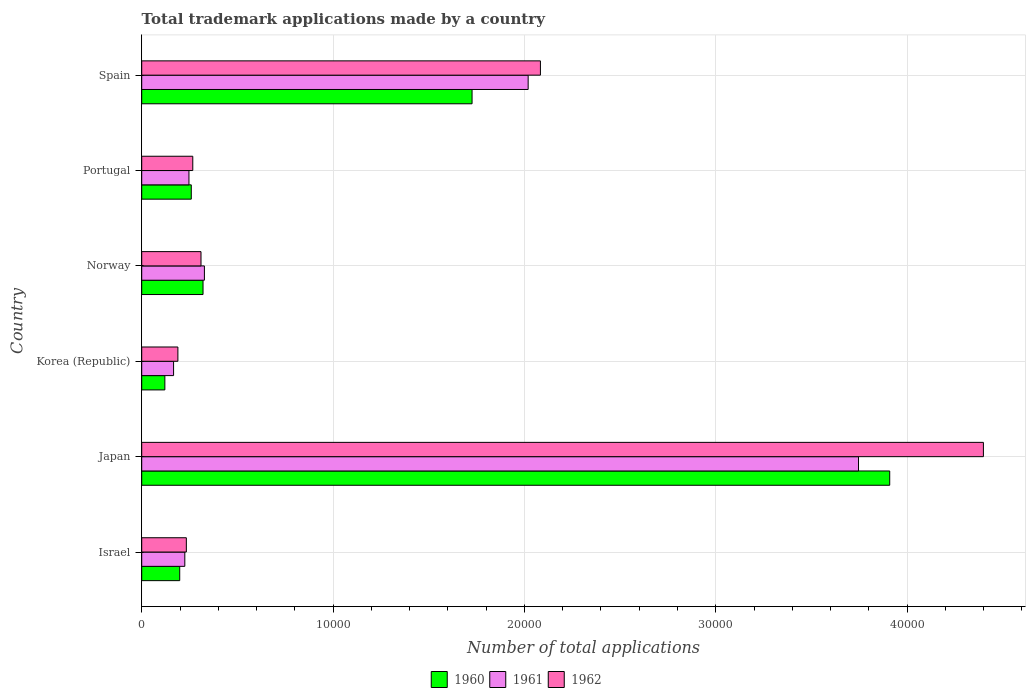Are the number of bars per tick equal to the number of legend labels?
Provide a succinct answer. Yes. Are the number of bars on each tick of the Y-axis equal?
Keep it short and to the point. Yes. What is the number of applications made by in 1960 in Korea (Republic)?
Your answer should be compact. 1209. Across all countries, what is the maximum number of applications made by in 1962?
Provide a succinct answer. 4.40e+04. Across all countries, what is the minimum number of applications made by in 1961?
Provide a short and direct response. 1665. In which country was the number of applications made by in 1962 maximum?
Your answer should be compact. Japan. What is the total number of applications made by in 1960 in the graph?
Your answer should be very brief. 6.53e+04. What is the difference between the number of applications made by in 1961 in Israel and that in Portugal?
Give a very brief answer. -216. What is the difference between the number of applications made by in 1962 in Israel and the number of applications made by in 1960 in Japan?
Make the answer very short. -3.68e+04. What is the average number of applications made by in 1961 per country?
Give a very brief answer. 1.12e+04. What is the difference between the number of applications made by in 1961 and number of applications made by in 1962 in Norway?
Provide a short and direct response. 178. In how many countries, is the number of applications made by in 1960 greater than 4000 ?
Keep it short and to the point. 2. What is the ratio of the number of applications made by in 1962 in Israel to that in Japan?
Give a very brief answer. 0.05. What is the difference between the highest and the second highest number of applications made by in 1962?
Your answer should be very brief. 2.32e+04. What is the difference between the highest and the lowest number of applications made by in 1961?
Keep it short and to the point. 3.58e+04. In how many countries, is the number of applications made by in 1962 greater than the average number of applications made by in 1962 taken over all countries?
Offer a terse response. 2. Is the sum of the number of applications made by in 1962 in Israel and Portugal greater than the maximum number of applications made by in 1961 across all countries?
Your answer should be compact. No. What does the 3rd bar from the top in Norway represents?
Keep it short and to the point. 1960. Is it the case that in every country, the sum of the number of applications made by in 1962 and number of applications made by in 1960 is greater than the number of applications made by in 1961?
Your answer should be compact. Yes. What is the difference between two consecutive major ticks on the X-axis?
Make the answer very short. 10000. Does the graph contain grids?
Give a very brief answer. Yes. Where does the legend appear in the graph?
Your response must be concise. Bottom center. What is the title of the graph?
Give a very brief answer. Total trademark applications made by a country. Does "1969" appear as one of the legend labels in the graph?
Offer a very short reply. No. What is the label or title of the X-axis?
Your answer should be compact. Number of total applications. What is the Number of total applications in 1960 in Israel?
Give a very brief answer. 1986. What is the Number of total applications of 1961 in Israel?
Give a very brief answer. 2252. What is the Number of total applications in 1962 in Israel?
Your response must be concise. 2332. What is the Number of total applications of 1960 in Japan?
Provide a succinct answer. 3.91e+04. What is the Number of total applications in 1961 in Japan?
Provide a short and direct response. 3.75e+04. What is the Number of total applications of 1962 in Japan?
Provide a short and direct response. 4.40e+04. What is the Number of total applications of 1960 in Korea (Republic)?
Your answer should be very brief. 1209. What is the Number of total applications in 1961 in Korea (Republic)?
Offer a very short reply. 1665. What is the Number of total applications of 1962 in Korea (Republic)?
Provide a short and direct response. 1890. What is the Number of total applications in 1960 in Norway?
Offer a terse response. 3204. What is the Number of total applications in 1961 in Norway?
Provide a succinct answer. 3276. What is the Number of total applications in 1962 in Norway?
Your answer should be very brief. 3098. What is the Number of total applications in 1960 in Portugal?
Keep it short and to the point. 2590. What is the Number of total applications in 1961 in Portugal?
Offer a terse response. 2468. What is the Number of total applications of 1962 in Portugal?
Give a very brief answer. 2668. What is the Number of total applications of 1960 in Spain?
Offer a terse response. 1.73e+04. What is the Number of total applications of 1961 in Spain?
Your answer should be very brief. 2.02e+04. What is the Number of total applications of 1962 in Spain?
Offer a very short reply. 2.08e+04. Across all countries, what is the maximum Number of total applications of 1960?
Your answer should be compact. 3.91e+04. Across all countries, what is the maximum Number of total applications of 1961?
Provide a short and direct response. 3.75e+04. Across all countries, what is the maximum Number of total applications of 1962?
Keep it short and to the point. 4.40e+04. Across all countries, what is the minimum Number of total applications of 1960?
Keep it short and to the point. 1209. Across all countries, what is the minimum Number of total applications of 1961?
Your answer should be very brief. 1665. Across all countries, what is the minimum Number of total applications of 1962?
Your answer should be very brief. 1890. What is the total Number of total applications in 1960 in the graph?
Give a very brief answer. 6.53e+04. What is the total Number of total applications in 1961 in the graph?
Provide a short and direct response. 6.73e+04. What is the total Number of total applications in 1962 in the graph?
Your answer should be compact. 7.48e+04. What is the difference between the Number of total applications in 1960 in Israel and that in Japan?
Offer a terse response. -3.71e+04. What is the difference between the Number of total applications in 1961 in Israel and that in Japan?
Make the answer very short. -3.52e+04. What is the difference between the Number of total applications in 1962 in Israel and that in Japan?
Provide a succinct answer. -4.17e+04. What is the difference between the Number of total applications in 1960 in Israel and that in Korea (Republic)?
Your answer should be compact. 777. What is the difference between the Number of total applications of 1961 in Israel and that in Korea (Republic)?
Provide a short and direct response. 587. What is the difference between the Number of total applications in 1962 in Israel and that in Korea (Republic)?
Your answer should be very brief. 442. What is the difference between the Number of total applications of 1960 in Israel and that in Norway?
Offer a terse response. -1218. What is the difference between the Number of total applications of 1961 in Israel and that in Norway?
Ensure brevity in your answer.  -1024. What is the difference between the Number of total applications in 1962 in Israel and that in Norway?
Offer a very short reply. -766. What is the difference between the Number of total applications in 1960 in Israel and that in Portugal?
Offer a terse response. -604. What is the difference between the Number of total applications of 1961 in Israel and that in Portugal?
Your answer should be very brief. -216. What is the difference between the Number of total applications in 1962 in Israel and that in Portugal?
Ensure brevity in your answer.  -336. What is the difference between the Number of total applications in 1960 in Israel and that in Spain?
Keep it short and to the point. -1.53e+04. What is the difference between the Number of total applications of 1961 in Israel and that in Spain?
Your answer should be very brief. -1.79e+04. What is the difference between the Number of total applications in 1962 in Israel and that in Spain?
Your answer should be compact. -1.85e+04. What is the difference between the Number of total applications of 1960 in Japan and that in Korea (Republic)?
Give a very brief answer. 3.79e+04. What is the difference between the Number of total applications of 1961 in Japan and that in Korea (Republic)?
Keep it short and to the point. 3.58e+04. What is the difference between the Number of total applications in 1962 in Japan and that in Korea (Republic)?
Your answer should be very brief. 4.21e+04. What is the difference between the Number of total applications in 1960 in Japan and that in Norway?
Offer a terse response. 3.59e+04. What is the difference between the Number of total applications of 1961 in Japan and that in Norway?
Give a very brief answer. 3.42e+04. What is the difference between the Number of total applications in 1962 in Japan and that in Norway?
Your answer should be compact. 4.09e+04. What is the difference between the Number of total applications of 1960 in Japan and that in Portugal?
Give a very brief answer. 3.65e+04. What is the difference between the Number of total applications of 1961 in Japan and that in Portugal?
Provide a short and direct response. 3.50e+04. What is the difference between the Number of total applications in 1962 in Japan and that in Portugal?
Ensure brevity in your answer.  4.13e+04. What is the difference between the Number of total applications in 1960 in Japan and that in Spain?
Ensure brevity in your answer.  2.18e+04. What is the difference between the Number of total applications in 1961 in Japan and that in Spain?
Your answer should be very brief. 1.73e+04. What is the difference between the Number of total applications in 1962 in Japan and that in Spain?
Offer a very short reply. 2.32e+04. What is the difference between the Number of total applications in 1960 in Korea (Republic) and that in Norway?
Your response must be concise. -1995. What is the difference between the Number of total applications of 1961 in Korea (Republic) and that in Norway?
Your answer should be compact. -1611. What is the difference between the Number of total applications in 1962 in Korea (Republic) and that in Norway?
Your answer should be very brief. -1208. What is the difference between the Number of total applications of 1960 in Korea (Republic) and that in Portugal?
Offer a very short reply. -1381. What is the difference between the Number of total applications of 1961 in Korea (Republic) and that in Portugal?
Your response must be concise. -803. What is the difference between the Number of total applications in 1962 in Korea (Republic) and that in Portugal?
Provide a short and direct response. -778. What is the difference between the Number of total applications in 1960 in Korea (Republic) and that in Spain?
Provide a short and direct response. -1.61e+04. What is the difference between the Number of total applications in 1961 in Korea (Republic) and that in Spain?
Your answer should be very brief. -1.85e+04. What is the difference between the Number of total applications of 1962 in Korea (Republic) and that in Spain?
Make the answer very short. -1.89e+04. What is the difference between the Number of total applications of 1960 in Norway and that in Portugal?
Make the answer very short. 614. What is the difference between the Number of total applications in 1961 in Norway and that in Portugal?
Provide a succinct answer. 808. What is the difference between the Number of total applications of 1962 in Norway and that in Portugal?
Offer a terse response. 430. What is the difference between the Number of total applications in 1960 in Norway and that in Spain?
Make the answer very short. -1.41e+04. What is the difference between the Number of total applications in 1961 in Norway and that in Spain?
Make the answer very short. -1.69e+04. What is the difference between the Number of total applications in 1962 in Norway and that in Spain?
Provide a short and direct response. -1.77e+04. What is the difference between the Number of total applications in 1960 in Portugal and that in Spain?
Offer a very short reply. -1.47e+04. What is the difference between the Number of total applications in 1961 in Portugal and that in Spain?
Keep it short and to the point. -1.77e+04. What is the difference between the Number of total applications in 1962 in Portugal and that in Spain?
Keep it short and to the point. -1.82e+04. What is the difference between the Number of total applications in 1960 in Israel and the Number of total applications in 1961 in Japan?
Make the answer very short. -3.55e+04. What is the difference between the Number of total applications of 1960 in Israel and the Number of total applications of 1962 in Japan?
Make the answer very short. -4.20e+04. What is the difference between the Number of total applications in 1961 in Israel and the Number of total applications in 1962 in Japan?
Your response must be concise. -4.17e+04. What is the difference between the Number of total applications in 1960 in Israel and the Number of total applications in 1961 in Korea (Republic)?
Offer a terse response. 321. What is the difference between the Number of total applications in 1960 in Israel and the Number of total applications in 1962 in Korea (Republic)?
Offer a terse response. 96. What is the difference between the Number of total applications in 1961 in Israel and the Number of total applications in 1962 in Korea (Republic)?
Your response must be concise. 362. What is the difference between the Number of total applications in 1960 in Israel and the Number of total applications in 1961 in Norway?
Offer a terse response. -1290. What is the difference between the Number of total applications in 1960 in Israel and the Number of total applications in 1962 in Norway?
Offer a very short reply. -1112. What is the difference between the Number of total applications in 1961 in Israel and the Number of total applications in 1962 in Norway?
Offer a very short reply. -846. What is the difference between the Number of total applications of 1960 in Israel and the Number of total applications of 1961 in Portugal?
Give a very brief answer. -482. What is the difference between the Number of total applications in 1960 in Israel and the Number of total applications in 1962 in Portugal?
Provide a succinct answer. -682. What is the difference between the Number of total applications in 1961 in Israel and the Number of total applications in 1962 in Portugal?
Your response must be concise. -416. What is the difference between the Number of total applications in 1960 in Israel and the Number of total applications in 1961 in Spain?
Give a very brief answer. -1.82e+04. What is the difference between the Number of total applications in 1960 in Israel and the Number of total applications in 1962 in Spain?
Ensure brevity in your answer.  -1.88e+04. What is the difference between the Number of total applications in 1961 in Israel and the Number of total applications in 1962 in Spain?
Ensure brevity in your answer.  -1.86e+04. What is the difference between the Number of total applications of 1960 in Japan and the Number of total applications of 1961 in Korea (Republic)?
Provide a short and direct response. 3.74e+04. What is the difference between the Number of total applications of 1960 in Japan and the Number of total applications of 1962 in Korea (Republic)?
Your answer should be compact. 3.72e+04. What is the difference between the Number of total applications in 1961 in Japan and the Number of total applications in 1962 in Korea (Republic)?
Your response must be concise. 3.56e+04. What is the difference between the Number of total applications of 1960 in Japan and the Number of total applications of 1961 in Norway?
Your answer should be compact. 3.58e+04. What is the difference between the Number of total applications in 1960 in Japan and the Number of total applications in 1962 in Norway?
Make the answer very short. 3.60e+04. What is the difference between the Number of total applications in 1961 in Japan and the Number of total applications in 1962 in Norway?
Your answer should be compact. 3.44e+04. What is the difference between the Number of total applications in 1960 in Japan and the Number of total applications in 1961 in Portugal?
Your answer should be very brief. 3.66e+04. What is the difference between the Number of total applications in 1960 in Japan and the Number of total applications in 1962 in Portugal?
Offer a terse response. 3.64e+04. What is the difference between the Number of total applications of 1961 in Japan and the Number of total applications of 1962 in Portugal?
Your answer should be compact. 3.48e+04. What is the difference between the Number of total applications in 1960 in Japan and the Number of total applications in 1961 in Spain?
Offer a terse response. 1.89e+04. What is the difference between the Number of total applications in 1960 in Japan and the Number of total applications in 1962 in Spain?
Your answer should be compact. 1.83e+04. What is the difference between the Number of total applications of 1961 in Japan and the Number of total applications of 1962 in Spain?
Your answer should be very brief. 1.66e+04. What is the difference between the Number of total applications in 1960 in Korea (Republic) and the Number of total applications in 1961 in Norway?
Offer a terse response. -2067. What is the difference between the Number of total applications of 1960 in Korea (Republic) and the Number of total applications of 1962 in Norway?
Offer a very short reply. -1889. What is the difference between the Number of total applications of 1961 in Korea (Republic) and the Number of total applications of 1962 in Norway?
Give a very brief answer. -1433. What is the difference between the Number of total applications in 1960 in Korea (Republic) and the Number of total applications in 1961 in Portugal?
Offer a terse response. -1259. What is the difference between the Number of total applications in 1960 in Korea (Republic) and the Number of total applications in 1962 in Portugal?
Provide a succinct answer. -1459. What is the difference between the Number of total applications in 1961 in Korea (Republic) and the Number of total applications in 1962 in Portugal?
Ensure brevity in your answer.  -1003. What is the difference between the Number of total applications of 1960 in Korea (Republic) and the Number of total applications of 1961 in Spain?
Offer a very short reply. -1.90e+04. What is the difference between the Number of total applications of 1960 in Korea (Republic) and the Number of total applications of 1962 in Spain?
Provide a short and direct response. -1.96e+04. What is the difference between the Number of total applications in 1961 in Korea (Republic) and the Number of total applications in 1962 in Spain?
Make the answer very short. -1.92e+04. What is the difference between the Number of total applications of 1960 in Norway and the Number of total applications of 1961 in Portugal?
Ensure brevity in your answer.  736. What is the difference between the Number of total applications in 1960 in Norway and the Number of total applications in 1962 in Portugal?
Offer a terse response. 536. What is the difference between the Number of total applications in 1961 in Norway and the Number of total applications in 1962 in Portugal?
Keep it short and to the point. 608. What is the difference between the Number of total applications of 1960 in Norway and the Number of total applications of 1961 in Spain?
Offer a very short reply. -1.70e+04. What is the difference between the Number of total applications of 1960 in Norway and the Number of total applications of 1962 in Spain?
Keep it short and to the point. -1.76e+04. What is the difference between the Number of total applications in 1961 in Norway and the Number of total applications in 1962 in Spain?
Keep it short and to the point. -1.76e+04. What is the difference between the Number of total applications of 1960 in Portugal and the Number of total applications of 1961 in Spain?
Your answer should be compact. -1.76e+04. What is the difference between the Number of total applications of 1960 in Portugal and the Number of total applications of 1962 in Spain?
Provide a succinct answer. -1.82e+04. What is the difference between the Number of total applications of 1961 in Portugal and the Number of total applications of 1962 in Spain?
Offer a very short reply. -1.84e+04. What is the average Number of total applications in 1960 per country?
Provide a short and direct response. 1.09e+04. What is the average Number of total applications of 1961 per country?
Offer a terse response. 1.12e+04. What is the average Number of total applications in 1962 per country?
Make the answer very short. 1.25e+04. What is the difference between the Number of total applications of 1960 and Number of total applications of 1961 in Israel?
Offer a terse response. -266. What is the difference between the Number of total applications in 1960 and Number of total applications in 1962 in Israel?
Provide a succinct answer. -346. What is the difference between the Number of total applications of 1961 and Number of total applications of 1962 in Israel?
Give a very brief answer. -80. What is the difference between the Number of total applications in 1960 and Number of total applications in 1961 in Japan?
Your answer should be compact. 1631. What is the difference between the Number of total applications of 1960 and Number of total applications of 1962 in Japan?
Your answer should be compact. -4896. What is the difference between the Number of total applications in 1961 and Number of total applications in 1962 in Japan?
Keep it short and to the point. -6527. What is the difference between the Number of total applications in 1960 and Number of total applications in 1961 in Korea (Republic)?
Provide a succinct answer. -456. What is the difference between the Number of total applications in 1960 and Number of total applications in 1962 in Korea (Republic)?
Provide a short and direct response. -681. What is the difference between the Number of total applications in 1961 and Number of total applications in 1962 in Korea (Republic)?
Your answer should be very brief. -225. What is the difference between the Number of total applications in 1960 and Number of total applications in 1961 in Norway?
Your response must be concise. -72. What is the difference between the Number of total applications of 1960 and Number of total applications of 1962 in Norway?
Ensure brevity in your answer.  106. What is the difference between the Number of total applications of 1961 and Number of total applications of 1962 in Norway?
Offer a very short reply. 178. What is the difference between the Number of total applications of 1960 and Number of total applications of 1961 in Portugal?
Keep it short and to the point. 122. What is the difference between the Number of total applications in 1960 and Number of total applications in 1962 in Portugal?
Provide a succinct answer. -78. What is the difference between the Number of total applications of 1961 and Number of total applications of 1962 in Portugal?
Your answer should be compact. -200. What is the difference between the Number of total applications in 1960 and Number of total applications in 1961 in Spain?
Make the answer very short. -2931. What is the difference between the Number of total applications of 1960 and Number of total applications of 1962 in Spain?
Keep it short and to the point. -3572. What is the difference between the Number of total applications in 1961 and Number of total applications in 1962 in Spain?
Ensure brevity in your answer.  -641. What is the ratio of the Number of total applications in 1960 in Israel to that in Japan?
Offer a very short reply. 0.05. What is the ratio of the Number of total applications of 1961 in Israel to that in Japan?
Give a very brief answer. 0.06. What is the ratio of the Number of total applications in 1962 in Israel to that in Japan?
Provide a short and direct response. 0.05. What is the ratio of the Number of total applications of 1960 in Israel to that in Korea (Republic)?
Give a very brief answer. 1.64. What is the ratio of the Number of total applications of 1961 in Israel to that in Korea (Republic)?
Your answer should be very brief. 1.35. What is the ratio of the Number of total applications in 1962 in Israel to that in Korea (Republic)?
Your answer should be very brief. 1.23. What is the ratio of the Number of total applications of 1960 in Israel to that in Norway?
Your answer should be very brief. 0.62. What is the ratio of the Number of total applications in 1961 in Israel to that in Norway?
Offer a very short reply. 0.69. What is the ratio of the Number of total applications of 1962 in Israel to that in Norway?
Your answer should be compact. 0.75. What is the ratio of the Number of total applications in 1960 in Israel to that in Portugal?
Give a very brief answer. 0.77. What is the ratio of the Number of total applications of 1961 in Israel to that in Portugal?
Keep it short and to the point. 0.91. What is the ratio of the Number of total applications in 1962 in Israel to that in Portugal?
Your answer should be very brief. 0.87. What is the ratio of the Number of total applications in 1960 in Israel to that in Spain?
Your answer should be compact. 0.12. What is the ratio of the Number of total applications of 1961 in Israel to that in Spain?
Provide a short and direct response. 0.11. What is the ratio of the Number of total applications in 1962 in Israel to that in Spain?
Your response must be concise. 0.11. What is the ratio of the Number of total applications in 1960 in Japan to that in Korea (Republic)?
Give a very brief answer. 32.33. What is the ratio of the Number of total applications in 1961 in Japan to that in Korea (Republic)?
Provide a succinct answer. 22.5. What is the ratio of the Number of total applications in 1962 in Japan to that in Korea (Republic)?
Make the answer very short. 23.27. What is the ratio of the Number of total applications in 1960 in Japan to that in Norway?
Keep it short and to the point. 12.2. What is the ratio of the Number of total applications of 1961 in Japan to that in Norway?
Your response must be concise. 11.43. What is the ratio of the Number of total applications in 1962 in Japan to that in Norway?
Provide a succinct answer. 14.2. What is the ratio of the Number of total applications of 1960 in Japan to that in Portugal?
Provide a succinct answer. 15.09. What is the ratio of the Number of total applications of 1961 in Japan to that in Portugal?
Give a very brief answer. 15.18. What is the ratio of the Number of total applications of 1962 in Japan to that in Portugal?
Ensure brevity in your answer.  16.49. What is the ratio of the Number of total applications in 1960 in Japan to that in Spain?
Keep it short and to the point. 2.26. What is the ratio of the Number of total applications in 1961 in Japan to that in Spain?
Make the answer very short. 1.85. What is the ratio of the Number of total applications of 1962 in Japan to that in Spain?
Provide a short and direct response. 2.11. What is the ratio of the Number of total applications in 1960 in Korea (Republic) to that in Norway?
Provide a short and direct response. 0.38. What is the ratio of the Number of total applications of 1961 in Korea (Republic) to that in Norway?
Ensure brevity in your answer.  0.51. What is the ratio of the Number of total applications of 1962 in Korea (Republic) to that in Norway?
Your answer should be very brief. 0.61. What is the ratio of the Number of total applications of 1960 in Korea (Republic) to that in Portugal?
Ensure brevity in your answer.  0.47. What is the ratio of the Number of total applications of 1961 in Korea (Republic) to that in Portugal?
Provide a short and direct response. 0.67. What is the ratio of the Number of total applications in 1962 in Korea (Republic) to that in Portugal?
Keep it short and to the point. 0.71. What is the ratio of the Number of total applications in 1960 in Korea (Republic) to that in Spain?
Provide a succinct answer. 0.07. What is the ratio of the Number of total applications of 1961 in Korea (Republic) to that in Spain?
Your response must be concise. 0.08. What is the ratio of the Number of total applications in 1962 in Korea (Republic) to that in Spain?
Ensure brevity in your answer.  0.09. What is the ratio of the Number of total applications of 1960 in Norway to that in Portugal?
Your answer should be compact. 1.24. What is the ratio of the Number of total applications of 1961 in Norway to that in Portugal?
Ensure brevity in your answer.  1.33. What is the ratio of the Number of total applications in 1962 in Norway to that in Portugal?
Keep it short and to the point. 1.16. What is the ratio of the Number of total applications of 1960 in Norway to that in Spain?
Your response must be concise. 0.19. What is the ratio of the Number of total applications of 1961 in Norway to that in Spain?
Make the answer very short. 0.16. What is the ratio of the Number of total applications in 1962 in Norway to that in Spain?
Give a very brief answer. 0.15. What is the ratio of the Number of total applications in 1961 in Portugal to that in Spain?
Provide a short and direct response. 0.12. What is the ratio of the Number of total applications of 1962 in Portugal to that in Spain?
Provide a succinct answer. 0.13. What is the difference between the highest and the second highest Number of total applications of 1960?
Your response must be concise. 2.18e+04. What is the difference between the highest and the second highest Number of total applications in 1961?
Offer a terse response. 1.73e+04. What is the difference between the highest and the second highest Number of total applications of 1962?
Offer a terse response. 2.32e+04. What is the difference between the highest and the lowest Number of total applications of 1960?
Offer a terse response. 3.79e+04. What is the difference between the highest and the lowest Number of total applications of 1961?
Keep it short and to the point. 3.58e+04. What is the difference between the highest and the lowest Number of total applications of 1962?
Provide a succinct answer. 4.21e+04. 